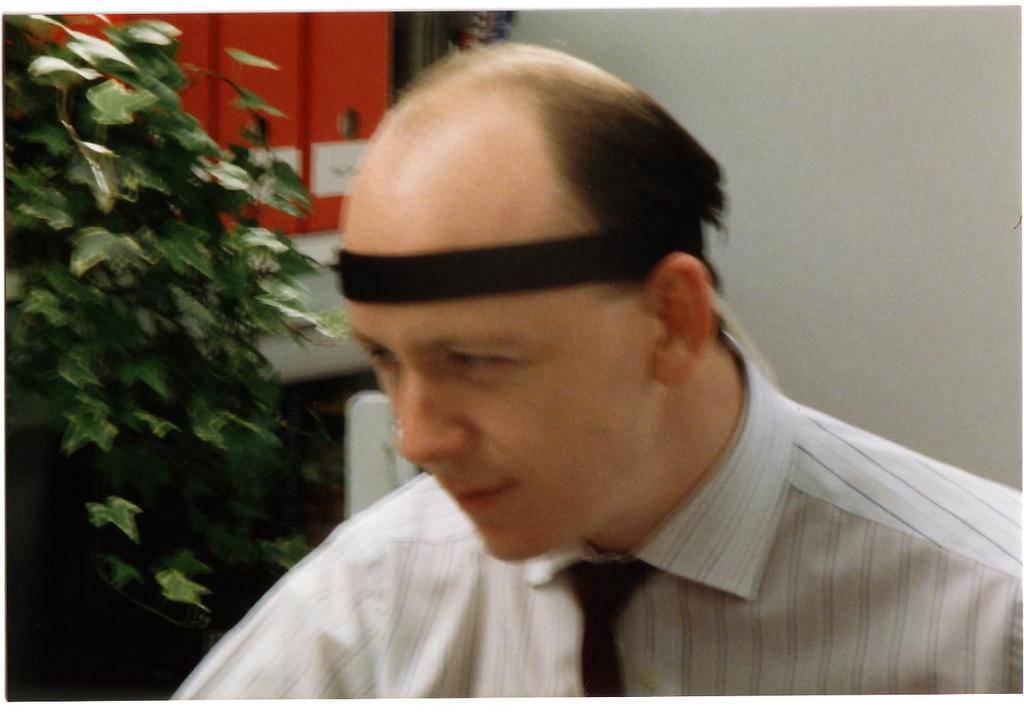Please provide a concise description of this image. In this image there is a man, on the left side there is a tree, in the background there is a wall. 